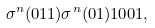Convert formula to latex. <formula><loc_0><loc_0><loc_500><loc_500>\sigma ^ { n } ( 0 1 1 ) \sigma ^ { n } ( 0 1 ) 1 0 0 1 ,</formula> 